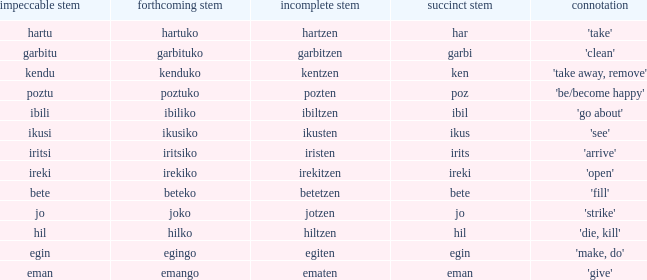What is the perfect stem for pozten? Poztu. 